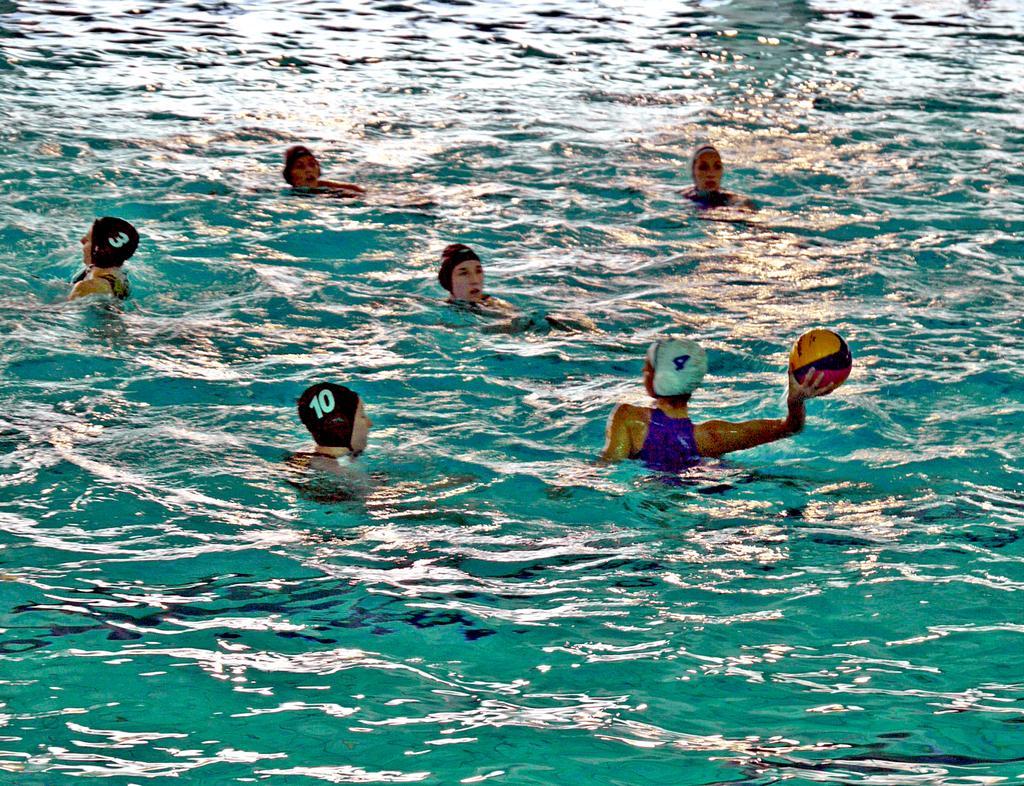Describe this image in one or two sentences. In this image few people are in the water. They are wearing caps. Right side a person is holding a ball in his hand. 